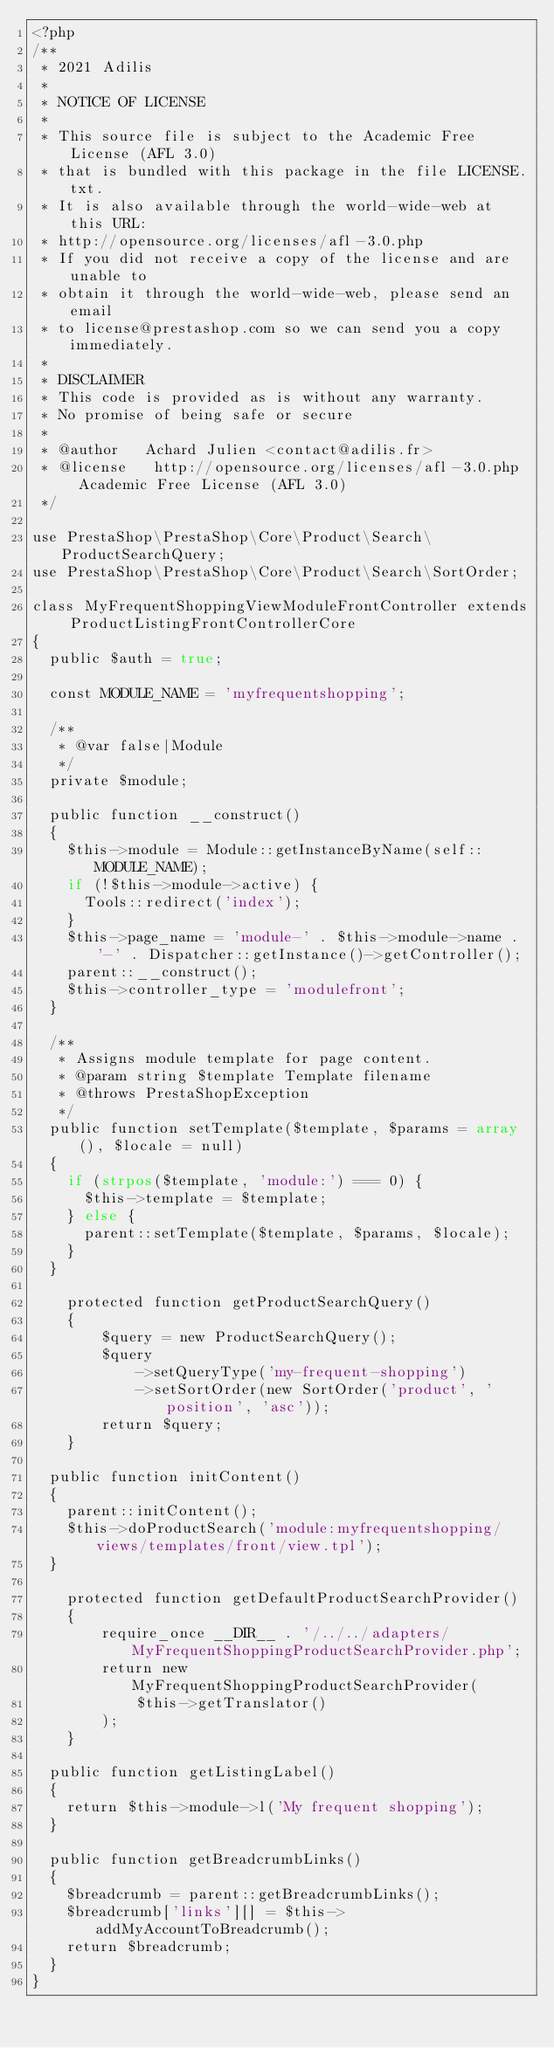Convert code to text. <code><loc_0><loc_0><loc_500><loc_500><_PHP_><?php
/**
 * 2021 Adilis
 *
 * NOTICE OF LICENSE
 *
 * This source file is subject to the Academic Free License (AFL 3.0)
 * that is bundled with this package in the file LICENSE.txt.
 * It is also available through the world-wide-web at this URL:
 * http://opensource.org/licenses/afl-3.0.php
 * If you did not receive a copy of the license and are unable to
 * obtain it through the world-wide-web, please send an email
 * to license@prestashop.com so we can send you a copy immediately.
 *
 * DISCLAIMER
 * This code is provided as is without any warranty.
 * No promise of being safe or secure
 *
 * @author   Achard Julien <contact@adilis.fr>
 * @license   http://opensource.org/licenses/afl-3.0.php  Academic Free License (AFL 3.0)
 */

use PrestaShop\PrestaShop\Core\Product\Search\ProductSearchQuery;
use PrestaShop\PrestaShop\Core\Product\Search\SortOrder;

class MyFrequentShoppingViewModuleFrontController extends ProductListingFrontControllerCore
{
	public $auth = true;

	const MODULE_NAME = 'myfrequentshopping';

	/**
	 * @var false|Module
	 */
	private $module;

	public function __construct()
	{
		$this->module = Module::getInstanceByName(self::MODULE_NAME);
		if (!$this->module->active) {
			Tools::redirect('index');
		}
		$this->page_name = 'module-' . $this->module->name . '-' . Dispatcher::getInstance()->getController();
		parent::__construct();
		$this->controller_type = 'modulefront';
	}

	/**
	 * Assigns module template for page content.
	 * @param string $template Template filename
	 * @throws PrestaShopException
	 */
	public function setTemplate($template, $params = array(), $locale = null)
	{
		if (strpos($template, 'module:') === 0) {
			$this->template = $template;
		} else {
			parent::setTemplate($template, $params, $locale);
		}
	}

    protected function getProductSearchQuery()
    {
        $query = new ProductSearchQuery();
        $query
            ->setQueryType('my-frequent-shopping')
            ->setSortOrder(new SortOrder('product', 'position', 'asc'));
        return $query;
    }

	public function initContent()
	{
		parent::initContent();
		$this->doProductSearch('module:myfrequentshopping/views/templates/front/view.tpl');
	}

    protected function getDefaultProductSearchProvider()
    {
        require_once __DIR__ . '/../../adapters/MyFrequentShoppingProductSearchProvider.php';
        return new MyFrequentShoppingProductSearchProvider(
            $this->getTranslator()
        );
    }

	public function getListingLabel()
	{
		return $this->module->l('My frequent shopping');
	}

	public function getBreadcrumbLinks()
	{
		$breadcrumb = parent::getBreadcrumbLinks();
		$breadcrumb['links'][] = $this->addMyAccountToBreadcrumb();
		return $breadcrumb;
	}
}
</code> 